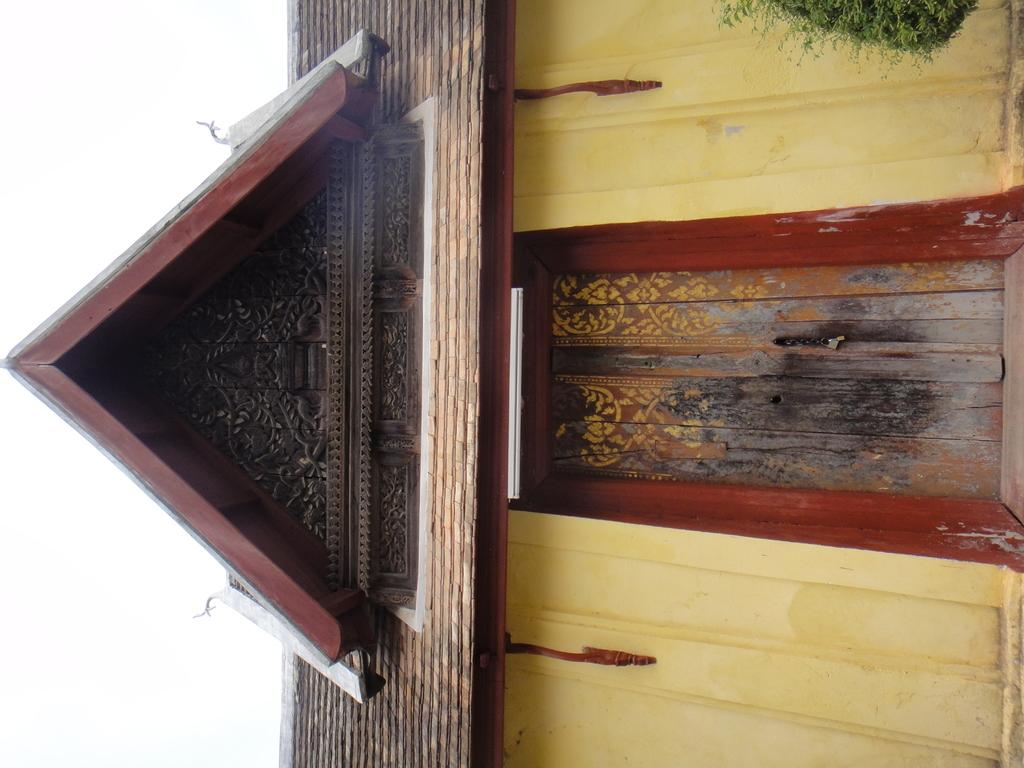What is the main subject of the picture? The main subject of the picture is a house. Can you describe any unique features of the house? Yes, there are designs on the roof of the house. What type of mint can be seen growing near the house in the image? There is no mint visible in the image; the focus is on the house and its roof designs. 